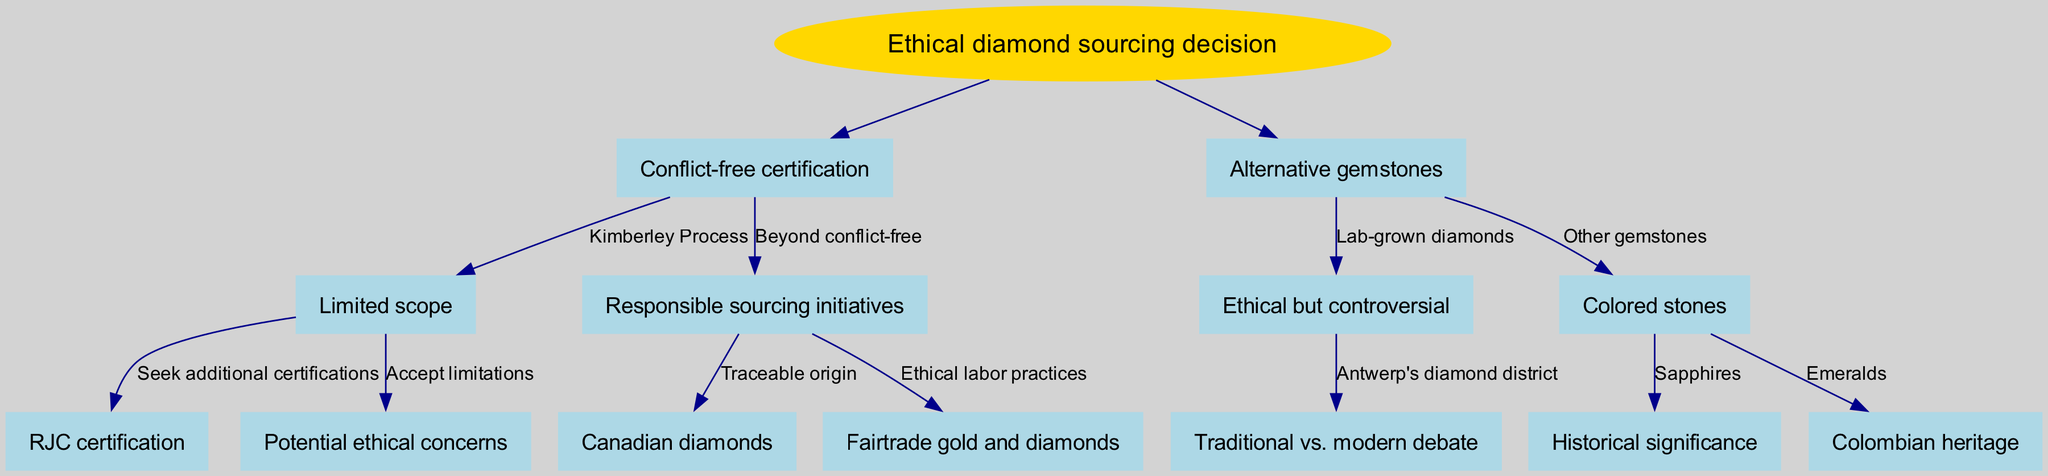What is the root of the decision tree? The root of the decision tree is explicitly stated in the data as "Ethical diamond sourcing decision." This is the starting point from which all branches flow.
Answer: Ethical diamond sourcing decision How many main branches are there? The diagram has two main branches originating from the root: "Conflict-free certification" and "Alternative gemstones." Each of these branches further divides into sub-branches.
Answer: 2 What certification is associated with the limited scope branch? Under the "Conflict-free certification" branch, "Kimberley Process" is specified as the certification with limited scope. This indicates a primary pathway of sourcing within this context.
Answer: Kimberley Process What is the node that focuses on ethical labor practices? The "Fairtrade gold and diamonds" node is specifically mentioned under the "Responsible sourcing initiatives" branch, indicating an ethical labor practice focus.
Answer: Fairtrade gold and diamonds How are lab-grown diamonds described in the diagram? "Ethical but controversial" is how the diagram characterizes lab-grown diamonds within the "Alternative gemstones" branch, highlighting a complex stance on their sourcing ethics.
Answer: Ethical but controversial Which stones are mentioned under the "Colored stones" node? The "Colored stones" node lists "Sapphires" and "Emeralds," indicating these types of gemstones are acknowledged in this section.
Answer: Sapphires and Emeralds What type of certification can be sought after the Kimberley Process? The diagram indicates that one can "Seek additional certifications" leading to the "RJC certification," suggesting a pathway for further ethical verification.
Answer: RJC certification Which location is associated with lab-grown diamond debates? The "Antwerp's diamond district" is linked to the "Traditional vs. modern debate," emphasizing a prominent discussion area for the topic of lab-grown diamonds.
Answer: Antwerp's diamond district What is a potential outcome of accepting the limitations of the Kimberley Process? Accepting the limitations leads to "Potential ethical concerns," emphasizing the risks associated with relying solely on this certification.
Answer: Potential ethical concerns 